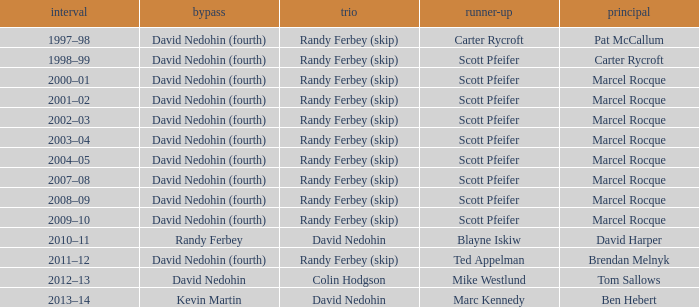Which Third has a Second of scott pfeifer? Randy Ferbey (skip), Randy Ferbey (skip), Randy Ferbey (skip), Randy Ferbey (skip), Randy Ferbey (skip), Randy Ferbey (skip), Randy Ferbey (skip), Randy Ferbey (skip), Randy Ferbey (skip). 